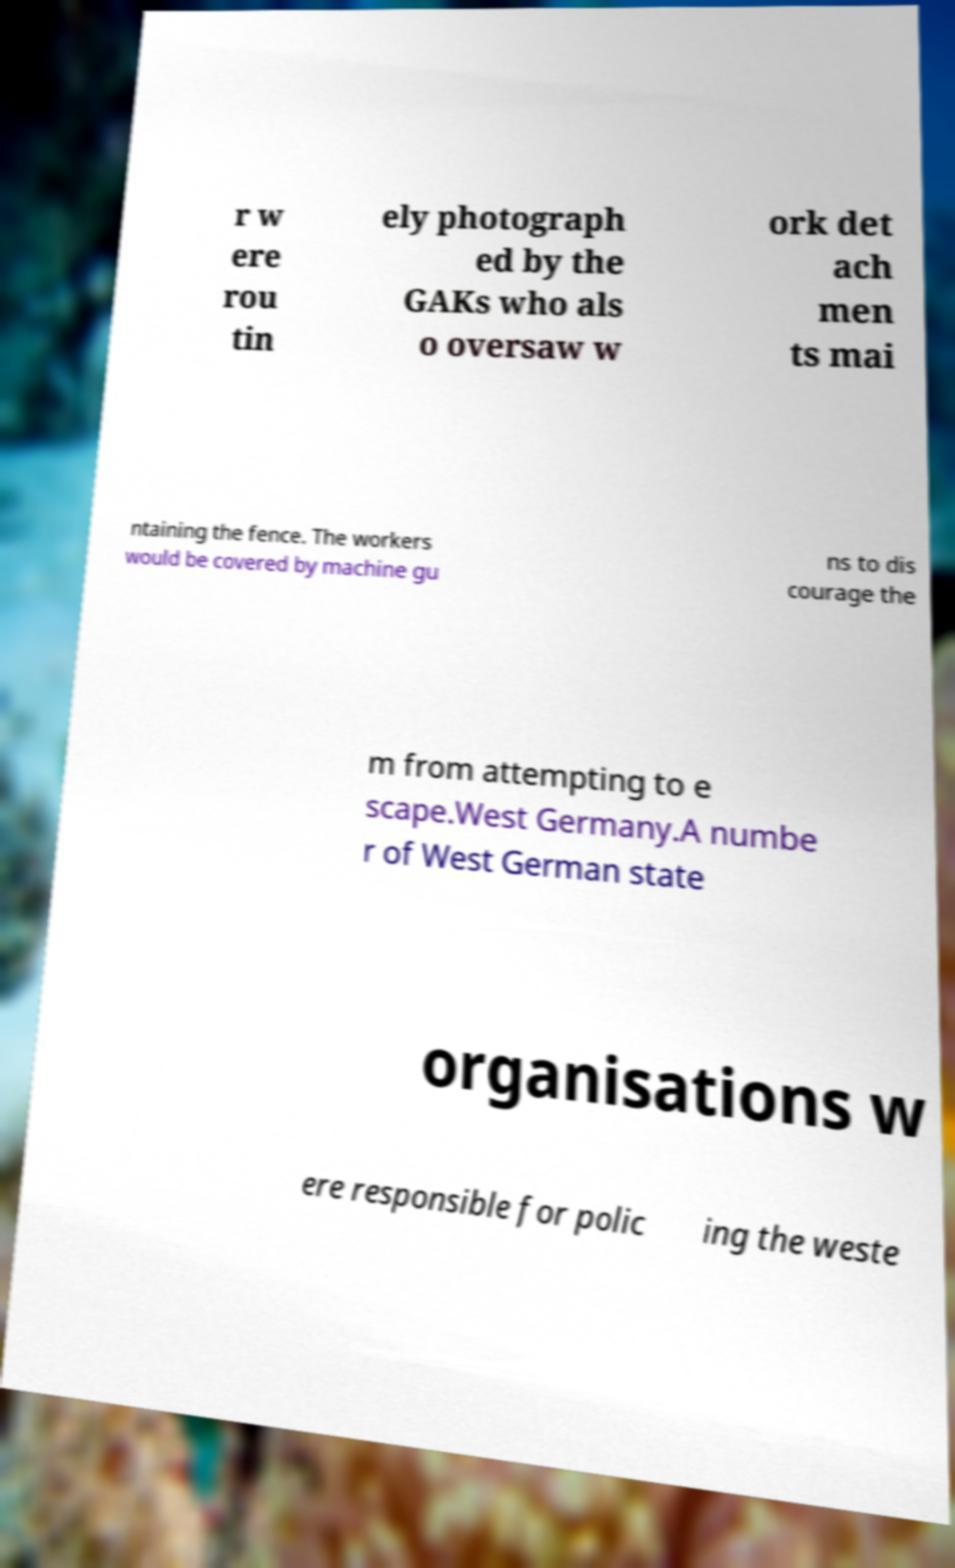I need the written content from this picture converted into text. Can you do that? r w ere rou tin ely photograph ed by the GAKs who als o oversaw w ork det ach men ts mai ntaining the fence. The workers would be covered by machine gu ns to dis courage the m from attempting to e scape.West Germany.A numbe r of West German state organisations w ere responsible for polic ing the weste 